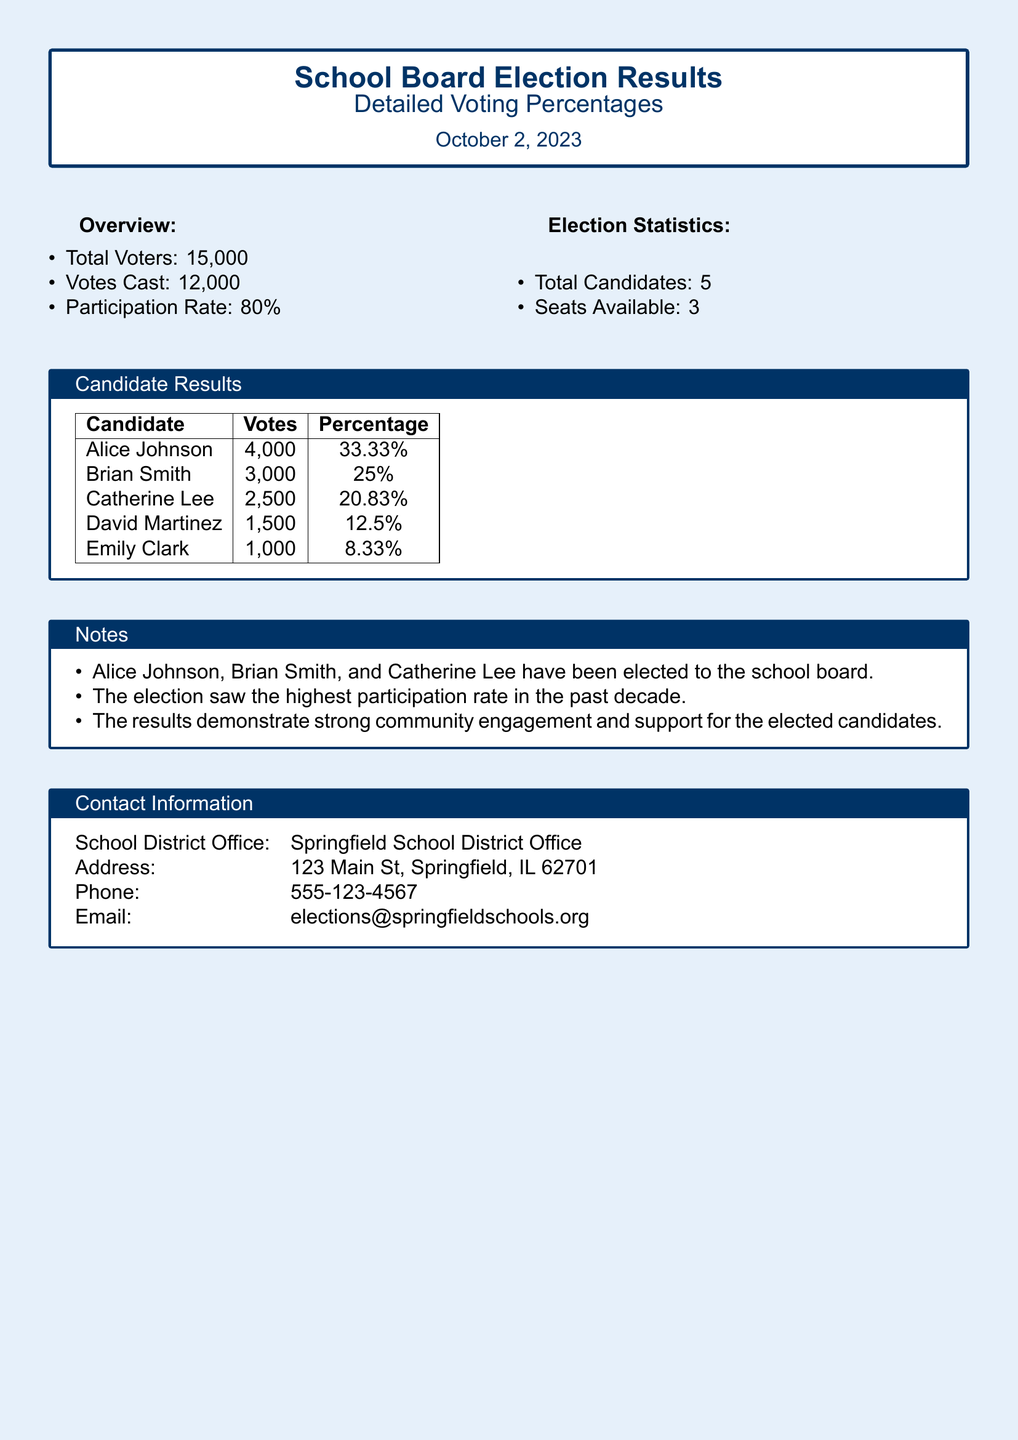What was the date of the election? The document states that the election took place on October 2, 2023.
Answer: October 2, 2023 How many total voters were there? The total number of voters listed in the overview section of the document is 15,000.
Answer: 15,000 Who received the most votes? According to the candidate results table, Alice Johnson received the highest number of votes, which was 4,000.
Answer: Alice Johnson What percentage of votes did David Martinez receive? The document indicates that David Martinez received 12.5% of the total votes cast.
Answer: 12.5% How many candidates were running in the election? The document states that there were a total of 5 candidates in the election.
Answer: 5 Which candidate was not elected to the school board? The document lists that David Martinez and Emily Clark were not among the elected candidates.
Answer: David Martinez What was the participation rate in the election? The participation rate, according to the overview section, was 80%.
Answer: 80% How many seats were available on the school board? The election statistics indicate that there were 3 seats available for election.
Answer: 3 What is the contact email for the school district office? The document provides the contact email as elections@springfieldschools.org.
Answer: elections@springfieldschools.org 